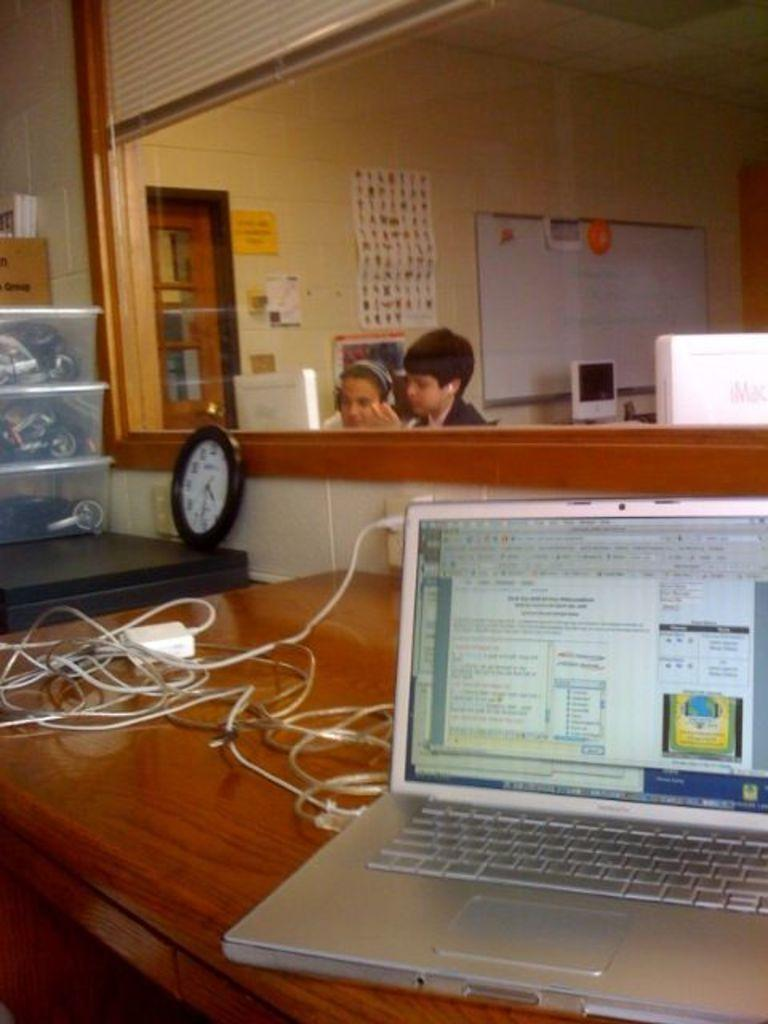What electronic device is on the table in the image? There is a laptop on the table in the image. What else can be seen on the table? There are wires on the table. What objects are beside the table? There are boxes and a watch beside the table. What are the two persons wearing? The two persons are wearing headsets. What can be seen in the background of the image? There is a wall, a chart, a board, and a door in the background. What type of lead is being used by the maid in the image? There is no maid or lead present in the image. How does the support system work for the persons wearing headsets in the image? The image does not show a support system for the persons wearing headsets; it only shows the headsets themselves. 